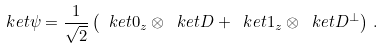Convert formula to latex. <formula><loc_0><loc_0><loc_500><loc_500>\ k e t { \psi } = \frac { 1 } { \sqrt { 2 } } \left ( \ k e t { 0 _ { z } } \otimes \ k e t D + \ k e t { 1 _ { z } } \otimes \ k e t { D ^ { \perp } } \right ) \, .</formula> 